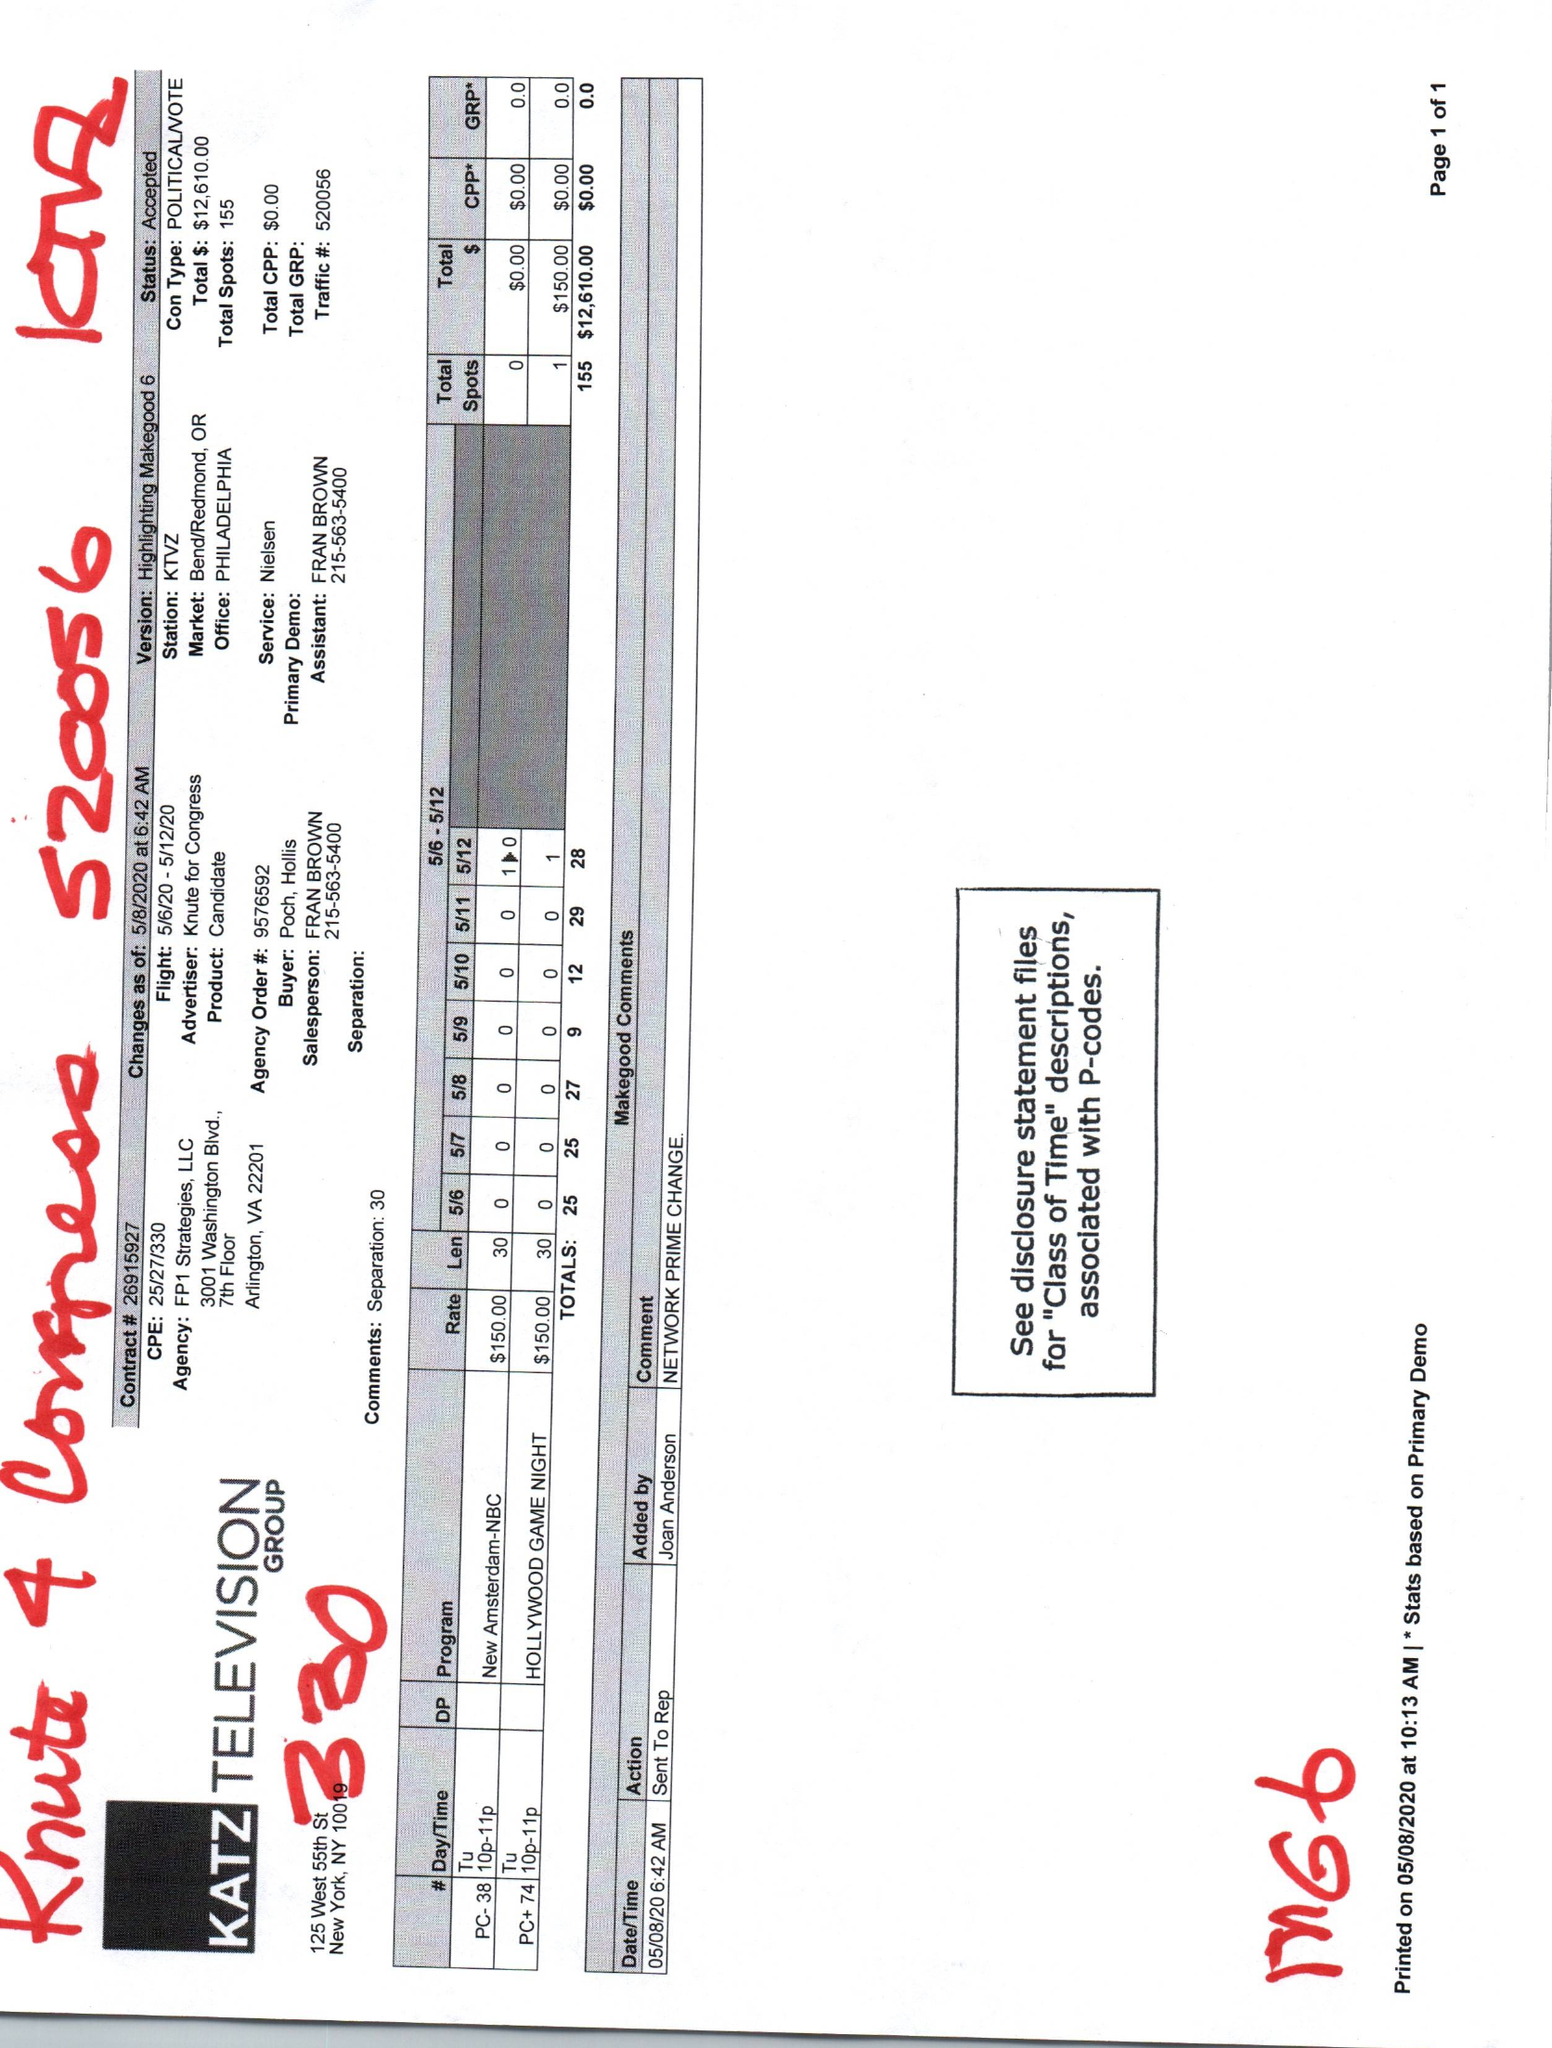What is the value for the advertiser?
Answer the question using a single word or phrase. KNUTE FOR CONGRESS 